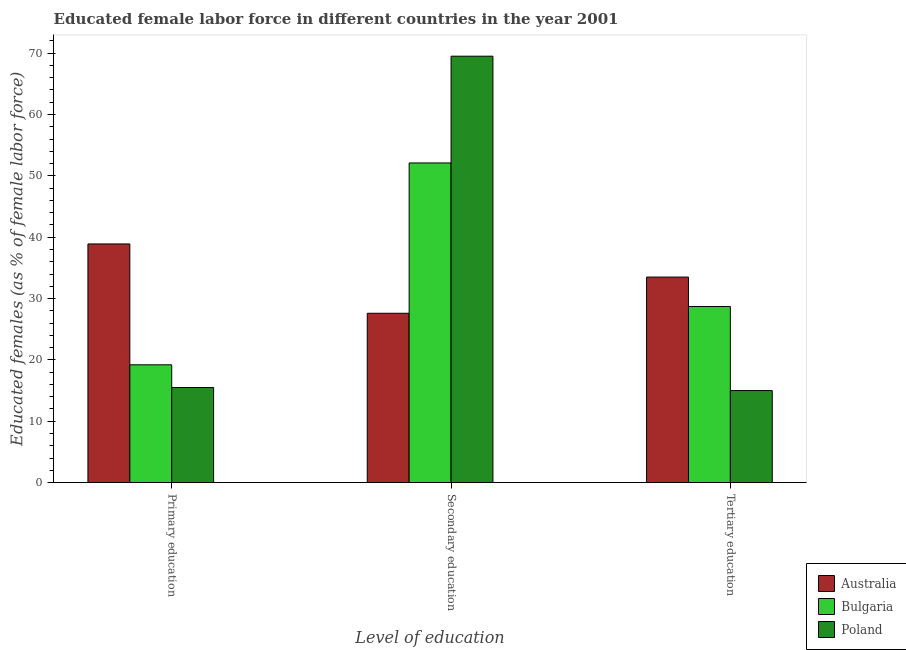Are the number of bars per tick equal to the number of legend labels?
Provide a succinct answer. Yes. What is the percentage of female labor force who received primary education in Australia?
Keep it short and to the point. 38.9. Across all countries, what is the maximum percentage of female labor force who received primary education?
Make the answer very short. 38.9. In which country was the percentage of female labor force who received tertiary education maximum?
Provide a short and direct response. Australia. What is the total percentage of female labor force who received primary education in the graph?
Make the answer very short. 73.6. What is the difference between the percentage of female labor force who received primary education in Poland and that in Australia?
Your answer should be very brief. -23.4. What is the difference between the percentage of female labor force who received secondary education in Australia and the percentage of female labor force who received primary education in Poland?
Offer a terse response. 12.1. What is the average percentage of female labor force who received tertiary education per country?
Your answer should be compact. 25.73. What is the difference between the percentage of female labor force who received tertiary education and percentage of female labor force who received secondary education in Australia?
Provide a succinct answer. 5.9. In how many countries, is the percentage of female labor force who received primary education greater than 50 %?
Your answer should be very brief. 0. What is the ratio of the percentage of female labor force who received tertiary education in Poland to that in Australia?
Your answer should be very brief. 0.45. Is the percentage of female labor force who received secondary education in Poland less than that in Australia?
Give a very brief answer. No. What is the difference between the highest and the second highest percentage of female labor force who received primary education?
Make the answer very short. 19.7. What is the difference between the highest and the lowest percentage of female labor force who received primary education?
Give a very brief answer. 23.4. Is the sum of the percentage of female labor force who received secondary education in Australia and Poland greater than the maximum percentage of female labor force who received primary education across all countries?
Ensure brevity in your answer.  Yes. What does the 3rd bar from the right in Primary education represents?
Provide a short and direct response. Australia. How many bars are there?
Provide a succinct answer. 9. Are all the bars in the graph horizontal?
Your answer should be very brief. No. What is the difference between two consecutive major ticks on the Y-axis?
Ensure brevity in your answer.  10. Does the graph contain any zero values?
Offer a very short reply. No. Does the graph contain grids?
Make the answer very short. No. Where does the legend appear in the graph?
Your answer should be compact. Bottom right. What is the title of the graph?
Your answer should be compact. Educated female labor force in different countries in the year 2001. What is the label or title of the X-axis?
Keep it short and to the point. Level of education. What is the label or title of the Y-axis?
Offer a very short reply. Educated females (as % of female labor force). What is the Educated females (as % of female labor force) of Australia in Primary education?
Offer a very short reply. 38.9. What is the Educated females (as % of female labor force) in Bulgaria in Primary education?
Your answer should be compact. 19.2. What is the Educated females (as % of female labor force) in Poland in Primary education?
Your answer should be very brief. 15.5. What is the Educated females (as % of female labor force) of Australia in Secondary education?
Make the answer very short. 27.6. What is the Educated females (as % of female labor force) in Bulgaria in Secondary education?
Your answer should be compact. 52.1. What is the Educated females (as % of female labor force) of Poland in Secondary education?
Make the answer very short. 69.5. What is the Educated females (as % of female labor force) in Australia in Tertiary education?
Ensure brevity in your answer.  33.5. What is the Educated females (as % of female labor force) of Bulgaria in Tertiary education?
Provide a short and direct response. 28.7. Across all Level of education, what is the maximum Educated females (as % of female labor force) in Australia?
Provide a succinct answer. 38.9. Across all Level of education, what is the maximum Educated females (as % of female labor force) in Bulgaria?
Ensure brevity in your answer.  52.1. Across all Level of education, what is the maximum Educated females (as % of female labor force) of Poland?
Keep it short and to the point. 69.5. Across all Level of education, what is the minimum Educated females (as % of female labor force) of Australia?
Provide a short and direct response. 27.6. Across all Level of education, what is the minimum Educated females (as % of female labor force) of Bulgaria?
Offer a very short reply. 19.2. What is the total Educated females (as % of female labor force) in Bulgaria in the graph?
Your response must be concise. 100. What is the total Educated females (as % of female labor force) in Poland in the graph?
Provide a succinct answer. 100. What is the difference between the Educated females (as % of female labor force) in Australia in Primary education and that in Secondary education?
Provide a short and direct response. 11.3. What is the difference between the Educated females (as % of female labor force) in Bulgaria in Primary education and that in Secondary education?
Offer a terse response. -32.9. What is the difference between the Educated females (as % of female labor force) of Poland in Primary education and that in Secondary education?
Your response must be concise. -54. What is the difference between the Educated females (as % of female labor force) of Bulgaria in Primary education and that in Tertiary education?
Your answer should be compact. -9.5. What is the difference between the Educated females (as % of female labor force) of Poland in Primary education and that in Tertiary education?
Offer a terse response. 0.5. What is the difference between the Educated females (as % of female labor force) of Bulgaria in Secondary education and that in Tertiary education?
Your answer should be very brief. 23.4. What is the difference between the Educated females (as % of female labor force) in Poland in Secondary education and that in Tertiary education?
Your answer should be very brief. 54.5. What is the difference between the Educated females (as % of female labor force) in Australia in Primary education and the Educated females (as % of female labor force) in Bulgaria in Secondary education?
Provide a short and direct response. -13.2. What is the difference between the Educated females (as % of female labor force) of Australia in Primary education and the Educated females (as % of female labor force) of Poland in Secondary education?
Provide a short and direct response. -30.6. What is the difference between the Educated females (as % of female labor force) of Bulgaria in Primary education and the Educated females (as % of female labor force) of Poland in Secondary education?
Your answer should be very brief. -50.3. What is the difference between the Educated females (as % of female labor force) in Australia in Primary education and the Educated females (as % of female labor force) in Bulgaria in Tertiary education?
Give a very brief answer. 10.2. What is the difference between the Educated females (as % of female labor force) of Australia in Primary education and the Educated females (as % of female labor force) of Poland in Tertiary education?
Offer a very short reply. 23.9. What is the difference between the Educated females (as % of female labor force) of Australia in Secondary education and the Educated females (as % of female labor force) of Bulgaria in Tertiary education?
Provide a succinct answer. -1.1. What is the difference between the Educated females (as % of female labor force) of Bulgaria in Secondary education and the Educated females (as % of female labor force) of Poland in Tertiary education?
Your response must be concise. 37.1. What is the average Educated females (as % of female labor force) in Australia per Level of education?
Provide a short and direct response. 33.33. What is the average Educated females (as % of female labor force) in Bulgaria per Level of education?
Provide a short and direct response. 33.33. What is the average Educated females (as % of female labor force) in Poland per Level of education?
Provide a short and direct response. 33.33. What is the difference between the Educated females (as % of female labor force) of Australia and Educated females (as % of female labor force) of Poland in Primary education?
Your response must be concise. 23.4. What is the difference between the Educated females (as % of female labor force) of Australia and Educated females (as % of female labor force) of Bulgaria in Secondary education?
Offer a very short reply. -24.5. What is the difference between the Educated females (as % of female labor force) in Australia and Educated females (as % of female labor force) in Poland in Secondary education?
Keep it short and to the point. -41.9. What is the difference between the Educated females (as % of female labor force) in Bulgaria and Educated females (as % of female labor force) in Poland in Secondary education?
Keep it short and to the point. -17.4. What is the difference between the Educated females (as % of female labor force) of Australia and Educated females (as % of female labor force) of Poland in Tertiary education?
Ensure brevity in your answer.  18.5. What is the ratio of the Educated females (as % of female labor force) of Australia in Primary education to that in Secondary education?
Provide a succinct answer. 1.41. What is the ratio of the Educated females (as % of female labor force) in Bulgaria in Primary education to that in Secondary education?
Provide a short and direct response. 0.37. What is the ratio of the Educated females (as % of female labor force) in Poland in Primary education to that in Secondary education?
Offer a terse response. 0.22. What is the ratio of the Educated females (as % of female labor force) of Australia in Primary education to that in Tertiary education?
Offer a very short reply. 1.16. What is the ratio of the Educated females (as % of female labor force) of Bulgaria in Primary education to that in Tertiary education?
Offer a very short reply. 0.67. What is the ratio of the Educated females (as % of female labor force) of Australia in Secondary education to that in Tertiary education?
Offer a very short reply. 0.82. What is the ratio of the Educated females (as % of female labor force) of Bulgaria in Secondary education to that in Tertiary education?
Give a very brief answer. 1.82. What is the ratio of the Educated females (as % of female labor force) of Poland in Secondary education to that in Tertiary education?
Make the answer very short. 4.63. What is the difference between the highest and the second highest Educated females (as % of female labor force) in Bulgaria?
Keep it short and to the point. 23.4. What is the difference between the highest and the lowest Educated females (as % of female labor force) of Bulgaria?
Ensure brevity in your answer.  32.9. What is the difference between the highest and the lowest Educated females (as % of female labor force) in Poland?
Your answer should be compact. 54.5. 